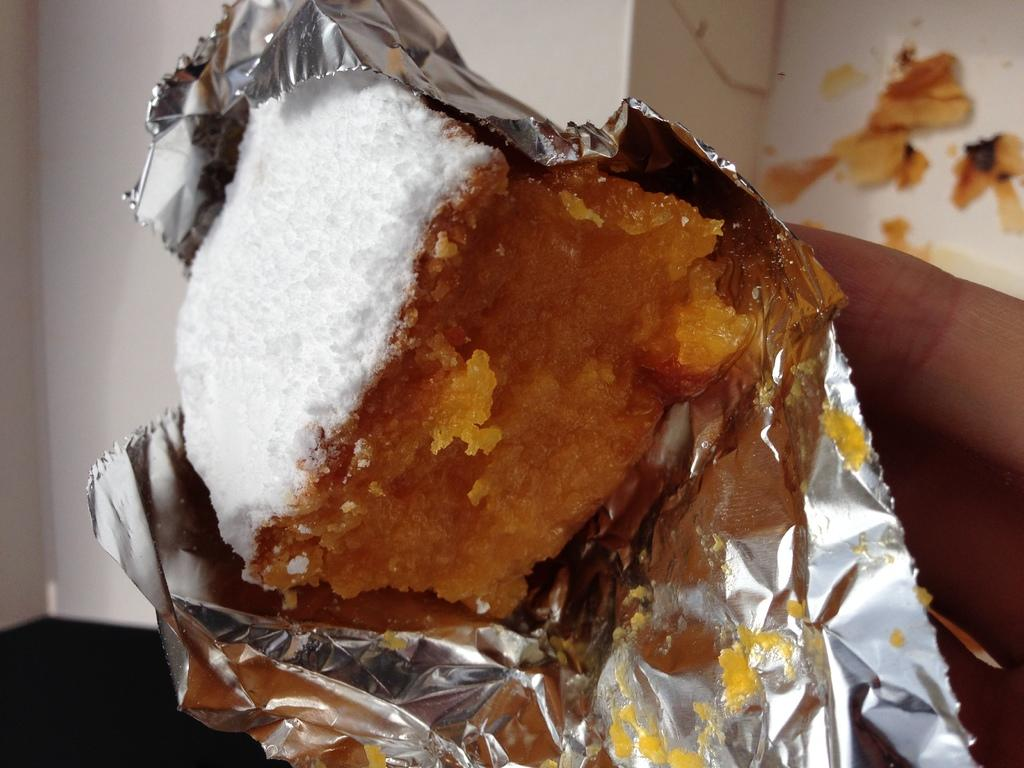What is the main subject of the image? There is a food item in the image. How is the food item being covered or protected? The food item is covered with aluminium foil. What color is the background of the image? The background of the image is white. What type of eggs are being taught how to use a spade in the image? There are no eggs or spades present in the image, and therefore no such activity can be observed. 